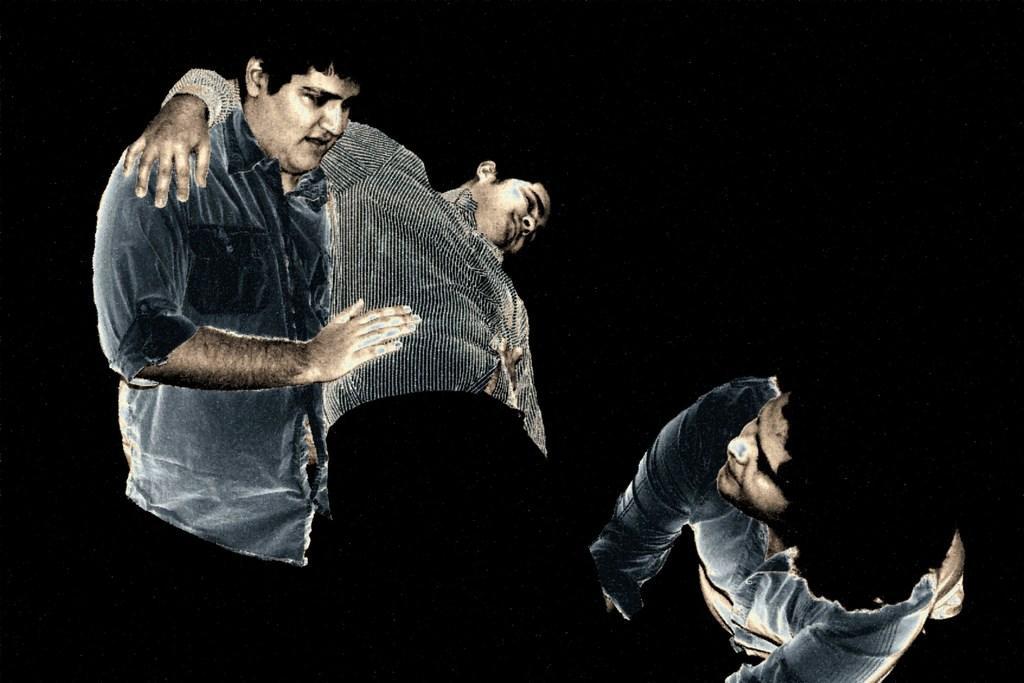Describe this image in one or two sentences. On the left side, there is a person in a shirt, holding another person. On the right side, there is another person, bending and holding the legs of the person. And the background is dark in color. 